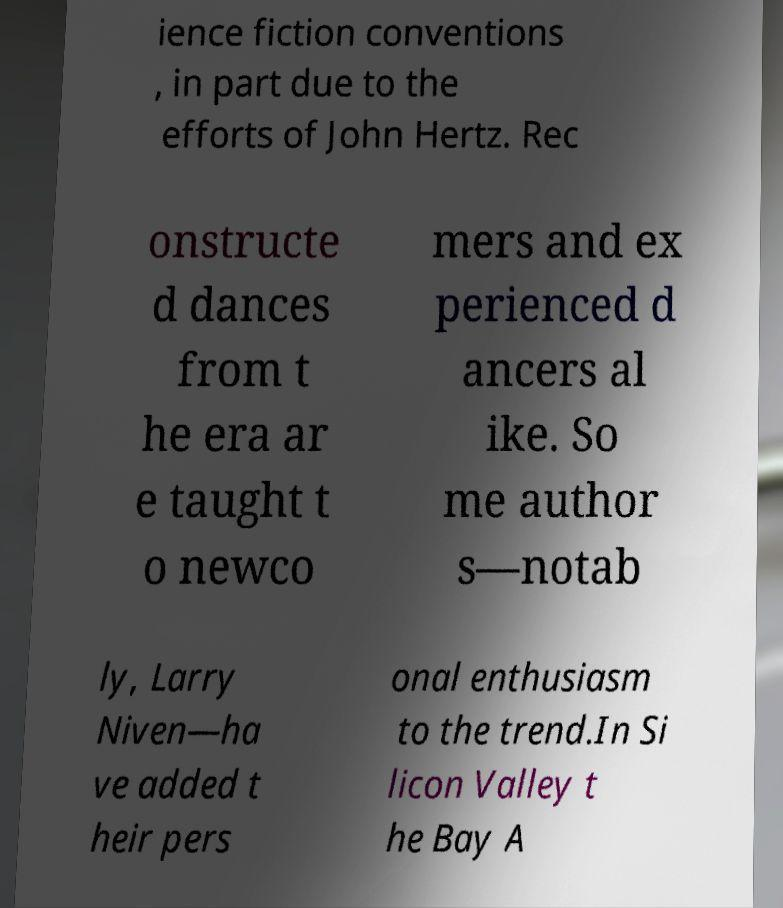There's text embedded in this image that I need extracted. Can you transcribe it verbatim? ience fiction conventions , in part due to the efforts of John Hertz. Rec onstructe d dances from t he era ar e taught t o newco mers and ex perienced d ancers al ike. So me author s—notab ly, Larry Niven—ha ve added t heir pers onal enthusiasm to the trend.In Si licon Valley t he Bay A 